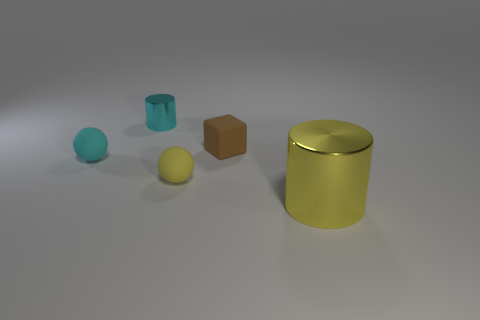Add 5 red cylinders. How many objects exist? 10 Add 5 tiny brown objects. How many tiny brown objects are left? 6 Add 3 tiny cyan shiny cylinders. How many tiny cyan shiny cylinders exist? 4 Subtract 1 yellow spheres. How many objects are left? 4 Subtract all cubes. How many objects are left? 4 Subtract 1 blocks. How many blocks are left? 0 Subtract all brown cylinders. Subtract all purple blocks. How many cylinders are left? 2 Subtract all yellow spheres. How many blue cylinders are left? 0 Subtract all yellow metallic cylinders. Subtract all cyan shiny objects. How many objects are left? 3 